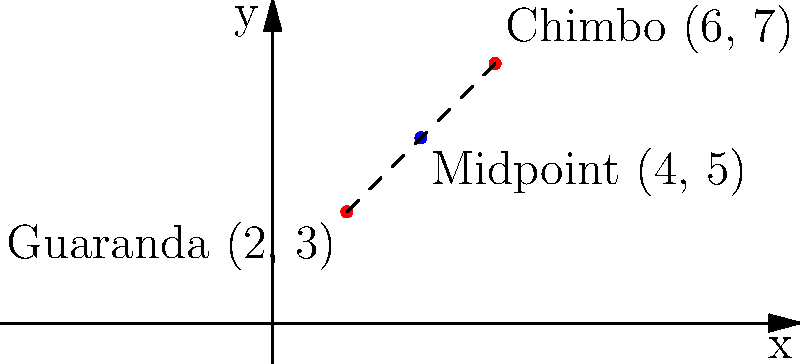Two prominent local politicians from Bolivar province, one from Guaranda and another from Chimbo, are planning to meet at the midpoint between their hometowns. Given that Guaranda is located at coordinates (2, 3) and Chimbo at (6, 7), find the coordinates of their meeting point. To find the midpoint between two points, we use the midpoint formula:

$$ \text{Midpoint} = \left(\frac{x_1 + x_2}{2}, \frac{y_1 + y_2}{2}\right) $$

Where $(x_1, y_1)$ are the coordinates of the first point (Guaranda) and $(x_2, y_2)$ are the coordinates of the second point (Chimbo).

Step 1: Identify the coordinates
Guaranda: $(x_1, y_1) = (2, 3)$
Chimbo: $(x_2, y_2) = (6, 7)$

Step 2: Calculate the x-coordinate of the midpoint
$$ x = \frac{x_1 + x_2}{2} = \frac{2 + 6}{2} = \frac{8}{2} = 4 $$

Step 3: Calculate the y-coordinate of the midpoint
$$ y = \frac{y_1 + y_2}{2} = \frac{3 + 7}{2} = \frac{10}{2} = 5 $$

Step 4: Combine the results
The midpoint coordinates are (4, 5).
Answer: (4, 5) 